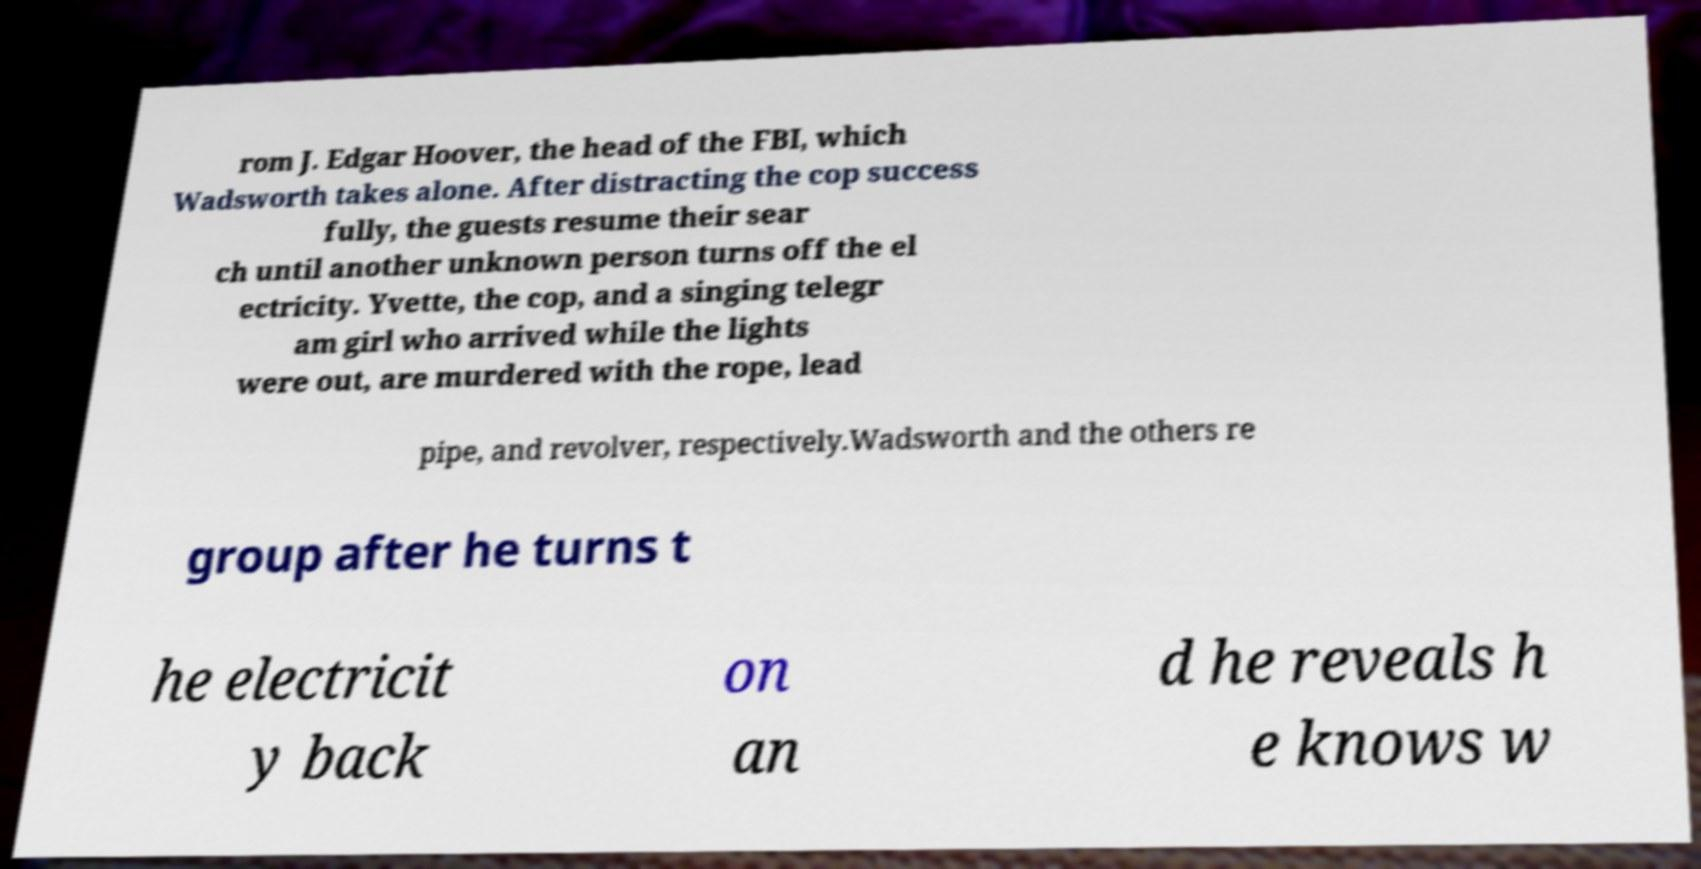Could you extract and type out the text from this image? rom J. Edgar Hoover, the head of the FBI, which Wadsworth takes alone. After distracting the cop success fully, the guests resume their sear ch until another unknown person turns off the el ectricity. Yvette, the cop, and a singing telegr am girl who arrived while the lights were out, are murdered with the rope, lead pipe, and revolver, respectively.Wadsworth and the others re group after he turns t he electricit y back on an d he reveals h e knows w 